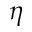<formula> <loc_0><loc_0><loc_500><loc_500>\eta</formula> 